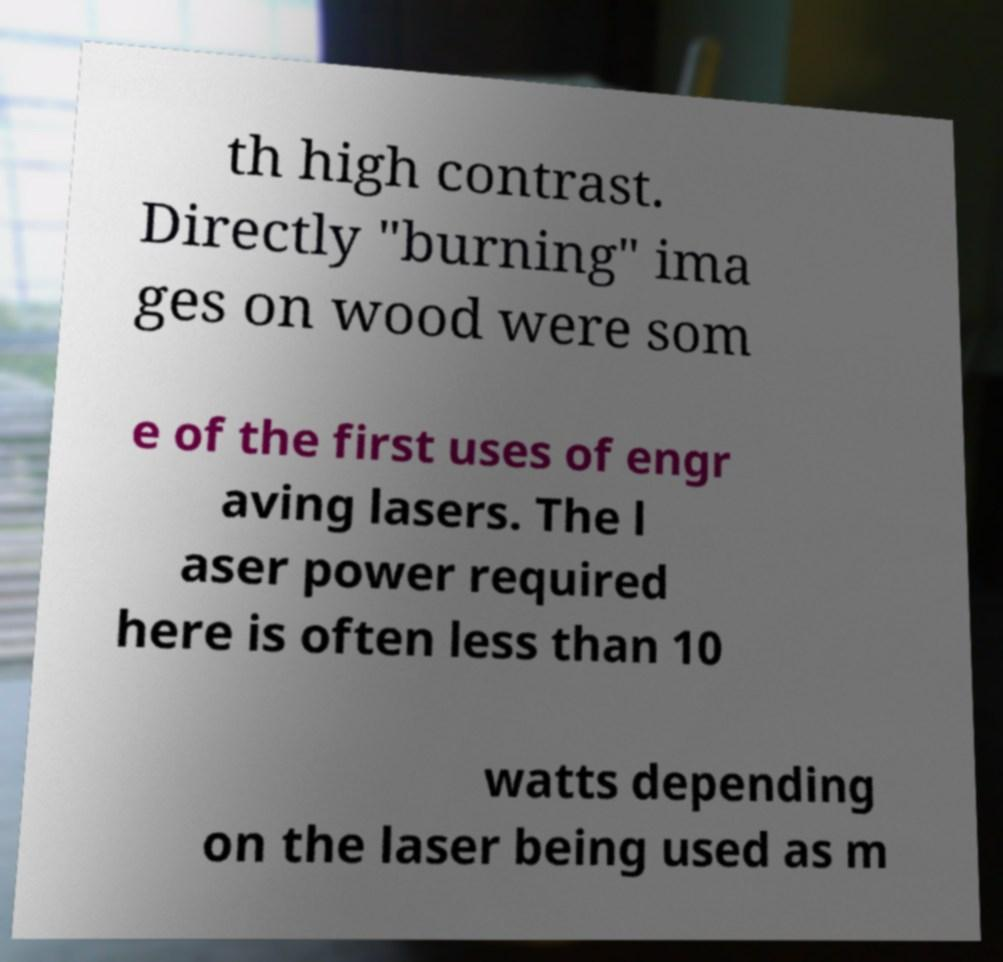Could you assist in decoding the text presented in this image and type it out clearly? th high contrast. Directly "burning" ima ges on wood were som e of the first uses of engr aving lasers. The l aser power required here is often less than 10 watts depending on the laser being used as m 